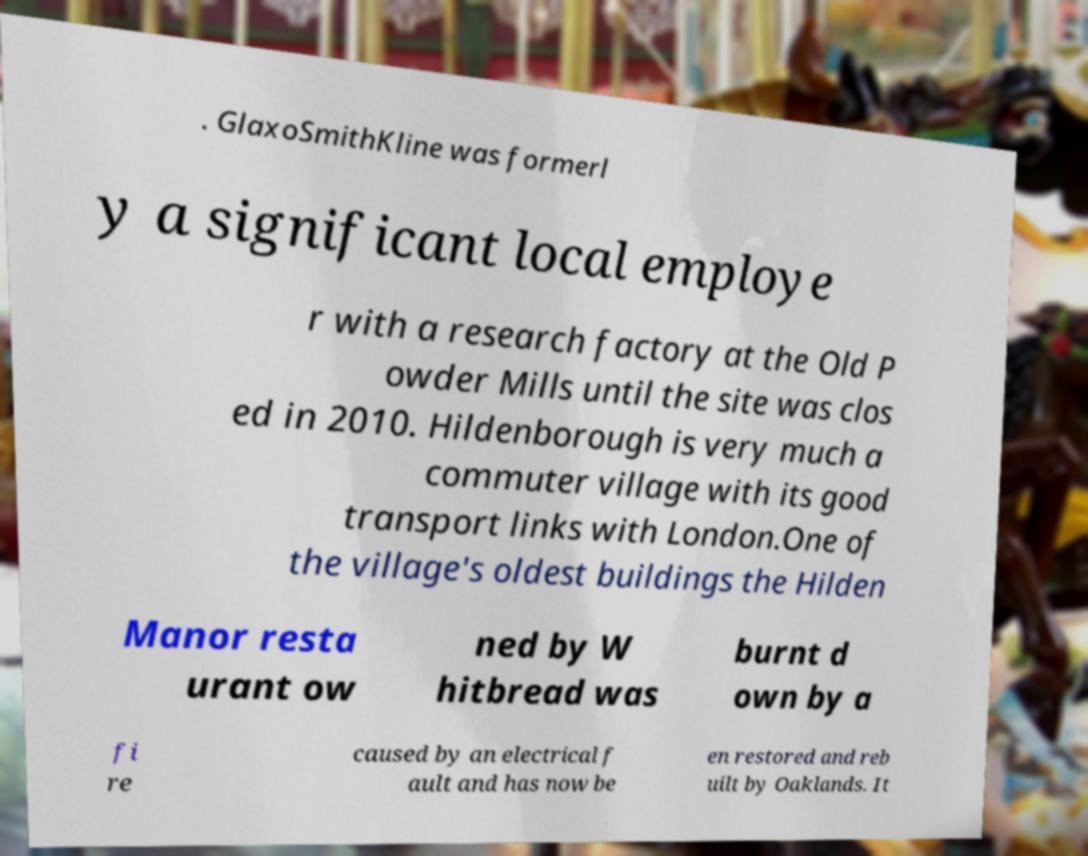For documentation purposes, I need the text within this image transcribed. Could you provide that? . GlaxoSmithKline was formerl y a significant local employe r with a research factory at the Old P owder Mills until the site was clos ed in 2010. Hildenborough is very much a commuter village with its good transport links with London.One of the village's oldest buildings the Hilden Manor resta urant ow ned by W hitbread was burnt d own by a fi re caused by an electrical f ault and has now be en restored and reb uilt by Oaklands. It 